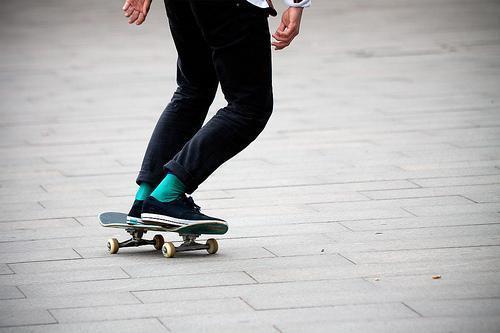How many people are in the picture?
Give a very brief answer. 1. 